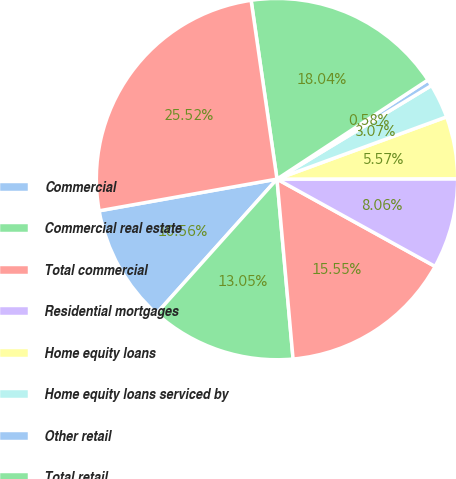<chart> <loc_0><loc_0><loc_500><loc_500><pie_chart><fcel>Commercial<fcel>Commercial real estate<fcel>Total commercial<fcel>Residential mortgages<fcel>Home equity loans<fcel>Home equity loans serviced by<fcel>Other retail<fcel>Total retail<fcel>Total<nl><fcel>10.56%<fcel>13.05%<fcel>15.55%<fcel>8.06%<fcel>5.57%<fcel>3.07%<fcel>0.58%<fcel>18.04%<fcel>25.52%<nl></chart> 